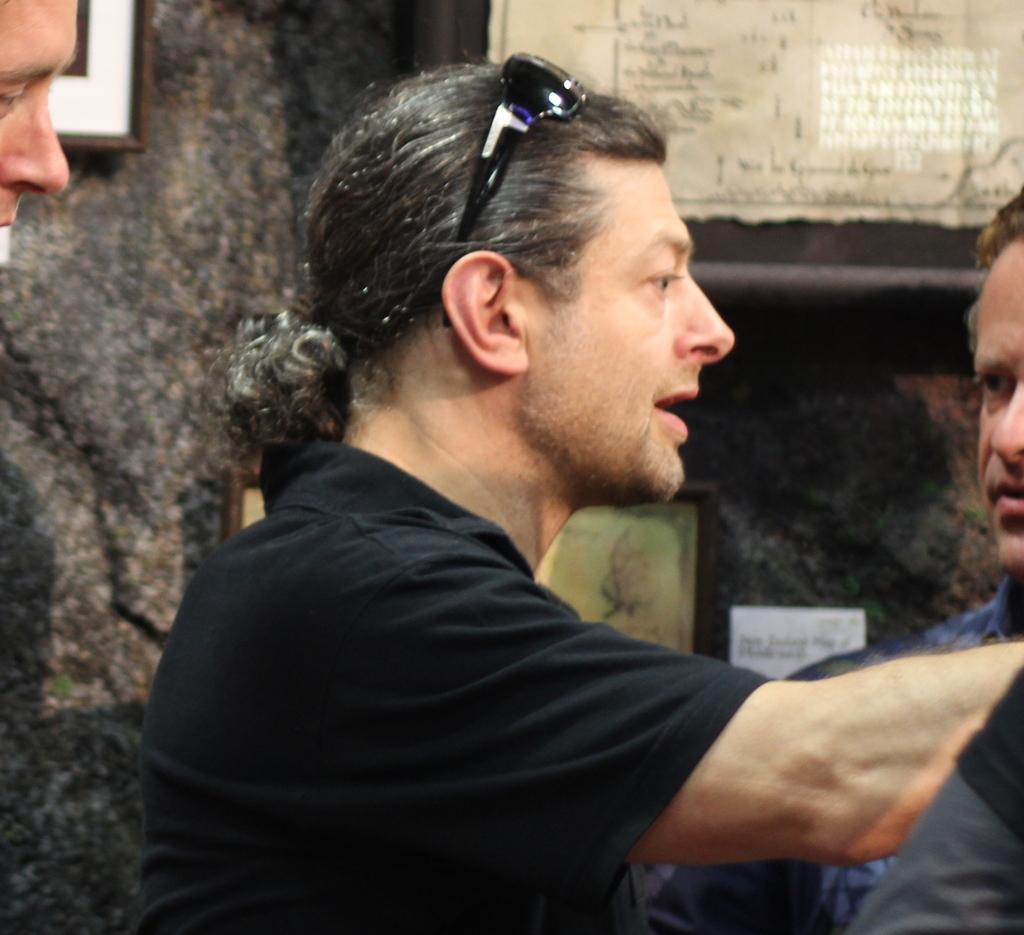Describe this image in one or two sentences. In the center of the image we can see a man with glasses and black t shirt. We can also see the other persons in this image. In the background there are frames and papers attached to the wall. 